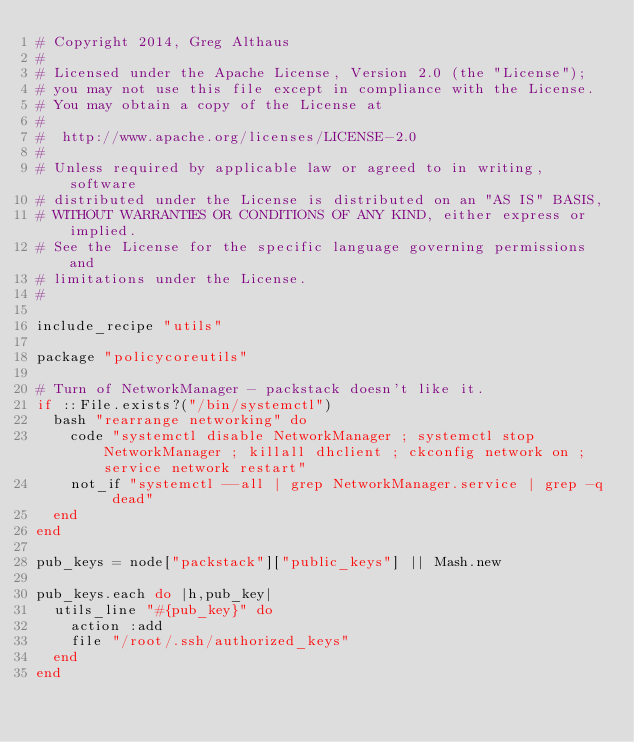Convert code to text. <code><loc_0><loc_0><loc_500><loc_500><_Ruby_># Copyright 2014, Greg Althaus
#
# Licensed under the Apache License, Version 2.0 (the "License");
# you may not use this file except in compliance with the License.
# You may obtain a copy of the License at
#
#  http://www.apache.org/licenses/LICENSE-2.0
#
# Unless required by applicable law or agreed to in writing, software
# distributed under the License is distributed on an "AS IS" BASIS,
# WITHOUT WARRANTIES OR CONDITIONS OF ANY KIND, either express or implied.
# See the License for the specific language governing permissions and
# limitations under the License.
#

include_recipe "utils"

package "policycoreutils"

# Turn of NetworkManager - packstack doesn't like it.
if ::File.exists?("/bin/systemctl")
  bash "rearrange networking" do
    code "systemctl disable NetworkManager ; systemctl stop NetworkManager ; killall dhclient ; ckconfig network on ; service network restart"
    not_if "systemctl --all | grep NetworkManager.service | grep -q dead"
  end
end

pub_keys = node["packstack"]["public_keys"] || Mash.new

pub_keys.each do |h,pub_key|
  utils_line "#{pub_key}" do
    action :add
    file "/root/.ssh/authorized_keys"
  end
end

</code> 